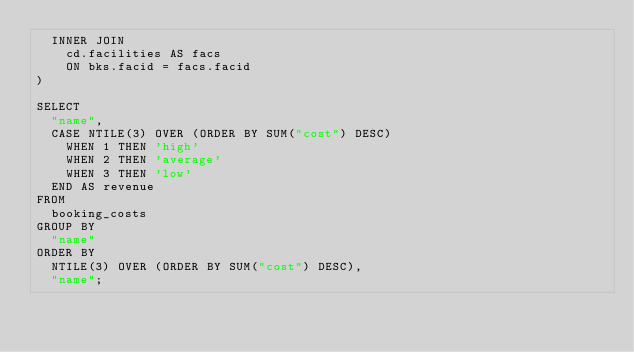<code> <loc_0><loc_0><loc_500><loc_500><_SQL_>  INNER JOIN
    cd.facilities AS facs
    ON bks.facid = facs.facid
)

SELECT
  "name",
  CASE NTILE(3) OVER (ORDER BY SUM("cost") DESC)
    WHEN 1 THEN 'high'
    WHEN 2 THEN 'average'
    WHEN 3 THEN 'low'
  END AS revenue
FROM
  booking_costs
GROUP BY
  "name"
ORDER BY
  NTILE(3) OVER (ORDER BY SUM("cost") DESC),
  "name";
</code> 